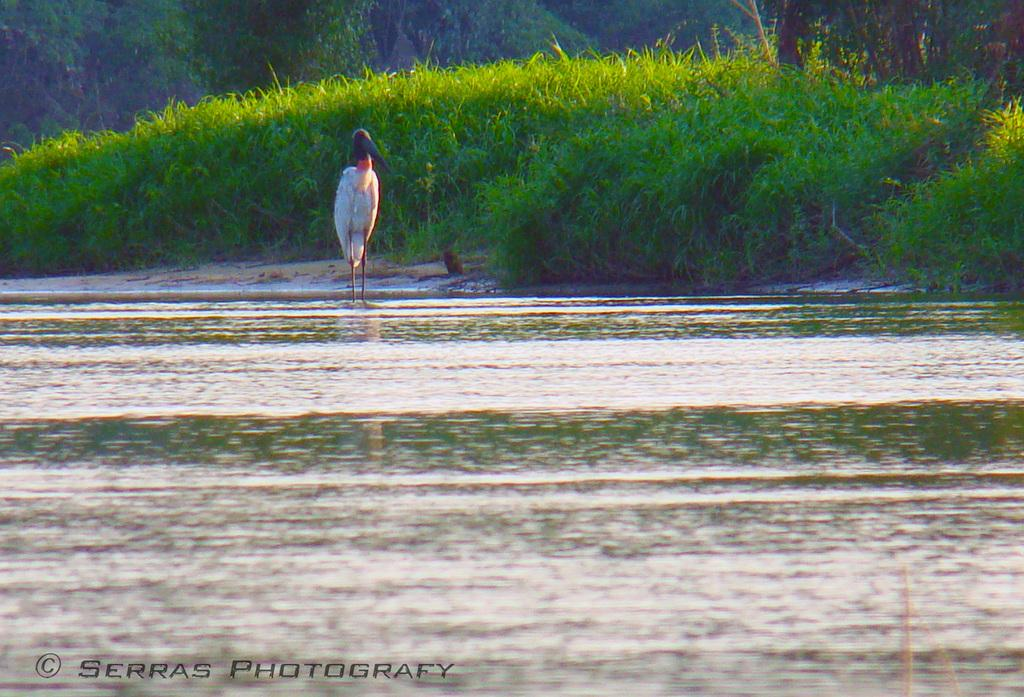What is the main subject of the image? There is a crane in the image. Where is the crane located? The crane is standing on the ground. What can be seen in the background of the image? There are trees, grass, and water visible in the background of the image. What type of marble is being used to build the crane in the image? There is no marble present in the image, as the crane is standing on the ground and not being built. What is the condition of the kite in the image? There is no kite present in the image. 